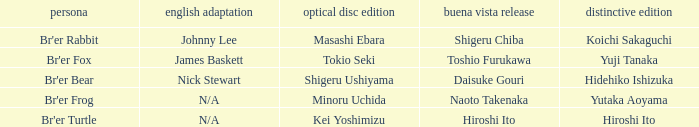Who is the character where the special edition is koichi sakaguchi? Br'er Rabbit. 